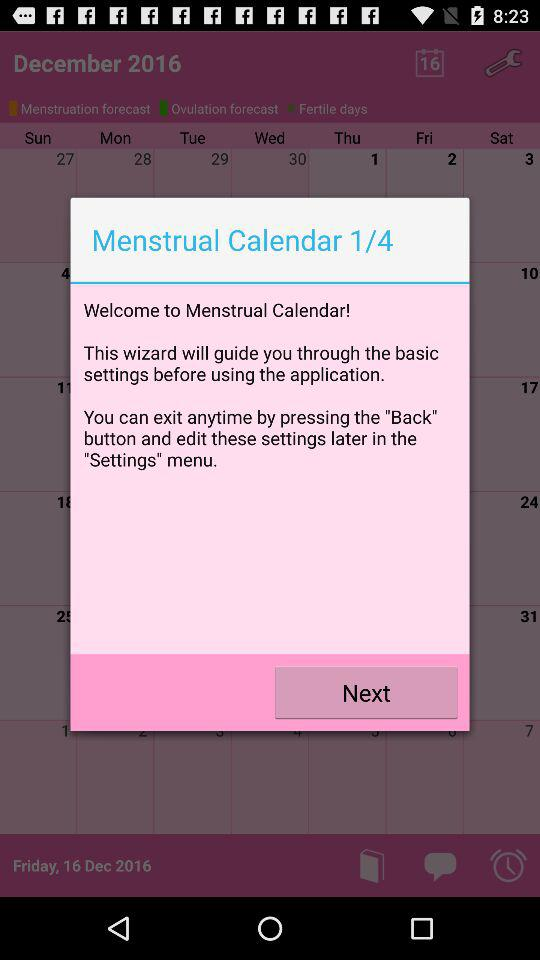What is the name of the application? The name of the application is "Menstrual Calendar". 